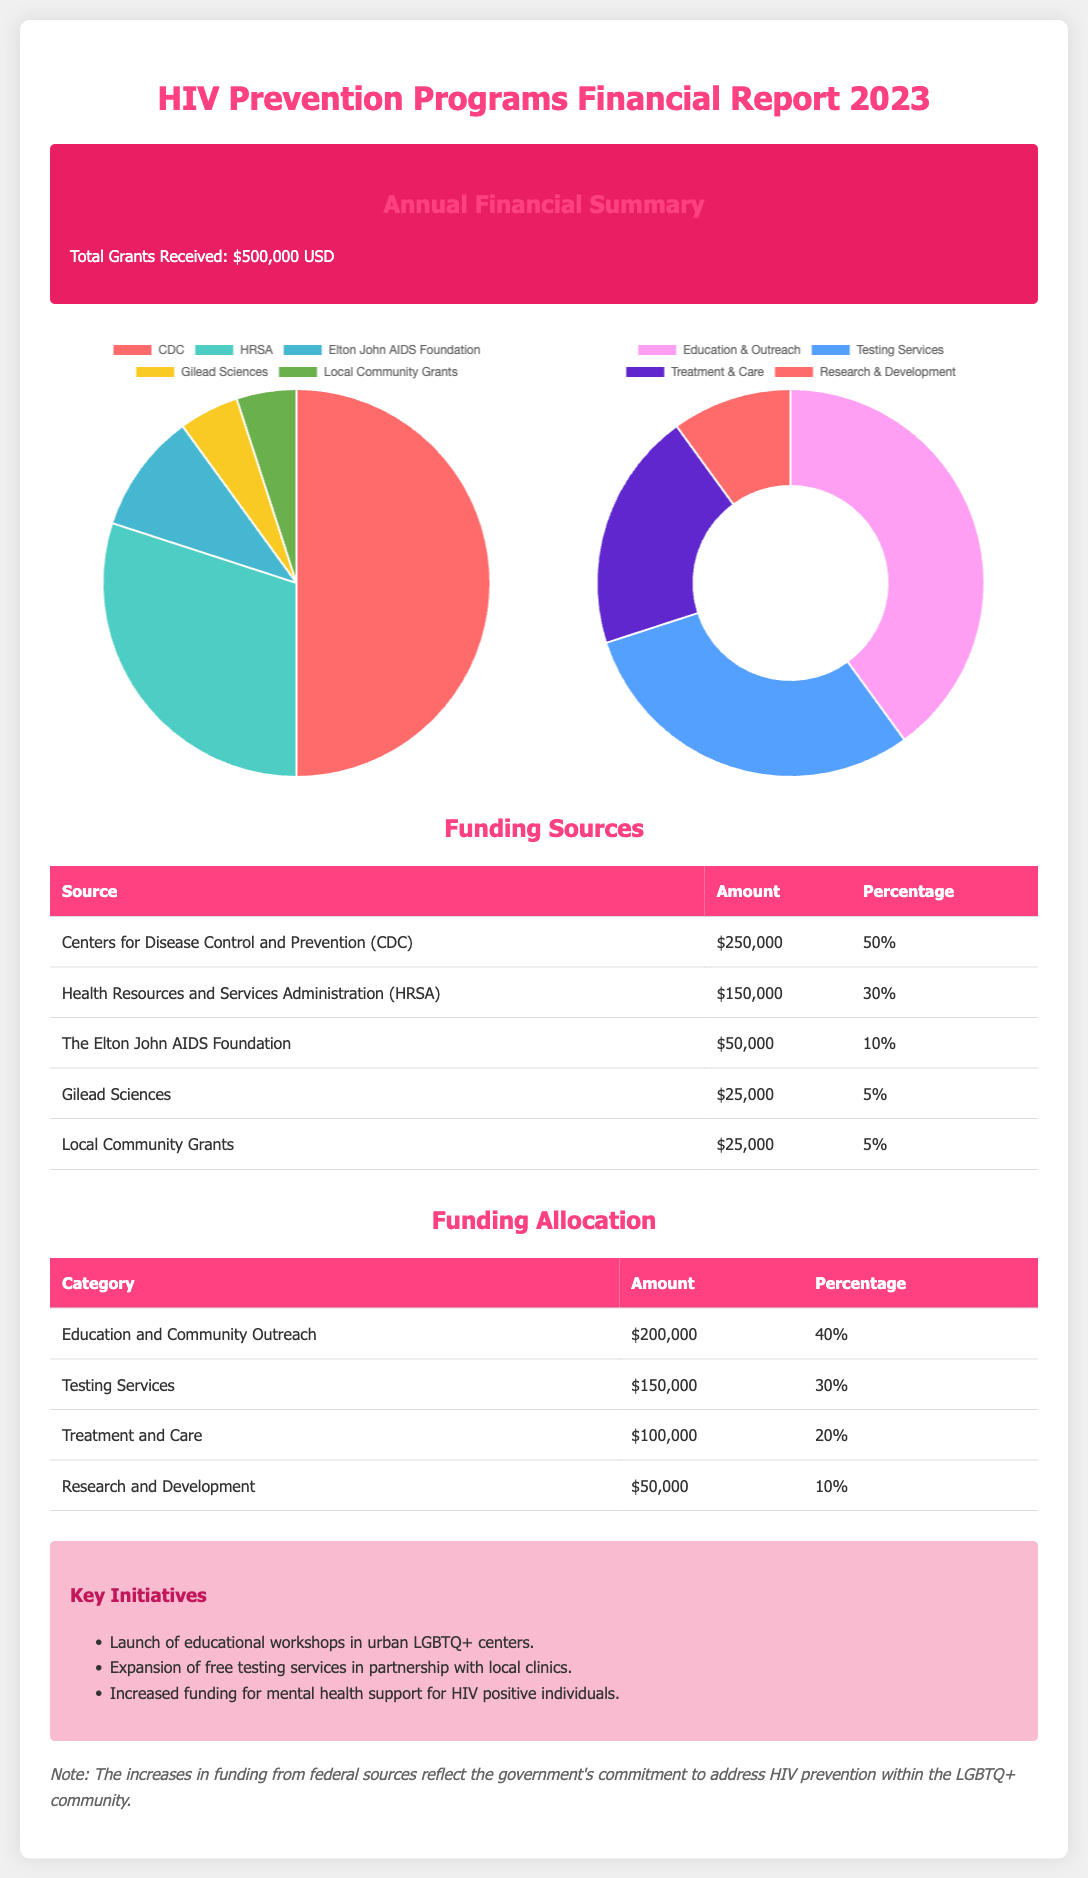What is the total grants received? The total grants received is stated directly in the summary section.
Answer: $500,000 USD Who is the largest funding source? The funding sources table lists amounts and percentages, making it clear that the largest source is the CDC.
Answer: Centers for Disease Control and Prevention (CDC) What percentage of funding is allocated to Education and Community Outreach? The funding allocation table indicates how much of the total funds have been directed toward Education and Community Outreach.
Answer: 40% How much funding was provided by the Elton John AIDS Foundation? The funding sources table shows the specific amount allocated from the Elton John AIDS Foundation.
Answer: $50,000 What is the smallest category of funding allocation? By examining the funding allocation table, we can identify the category with the least amount allocated.
Answer: Research and Development What percentage of total funding comes from local community grants? The funding sources table lists this percentage clearly among the entries for funding sources.
Answer: 5% What initiatives are emphasized in the key initiatives section? The key initiatives section highlights specific projects and efforts aimed at improving HIV prevention.
Answer: Educational workshops, free testing services, mental health support Which organization provided $25,000 for funding? The funding sources table lists the organizations and their contributions, clearly showing which provided $25,000.
Answer: Gilead Sciences What type of chart represents funding sources? The document describes the chart types used to visually represent financial data concerning funding sources.
Answer: Pie chart 